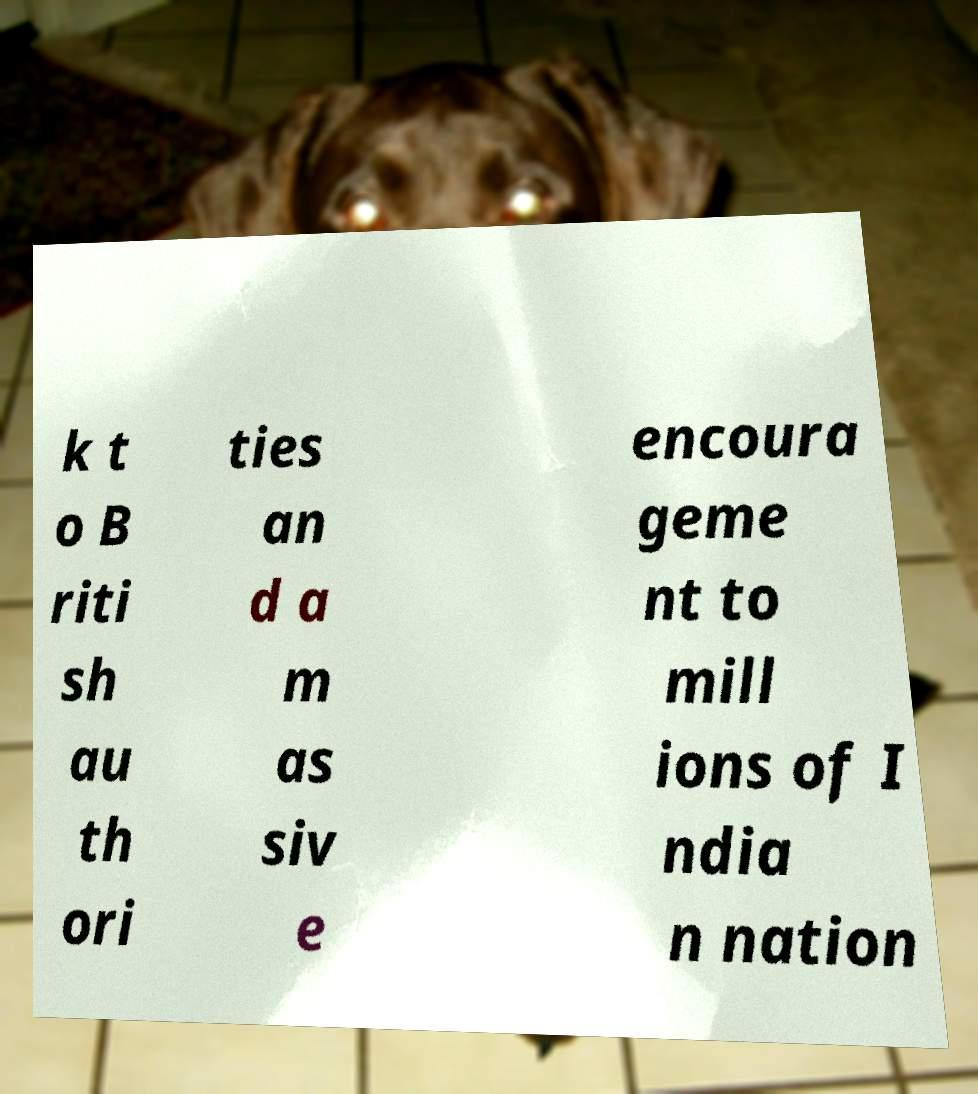Please identify and transcribe the text found in this image. k t o B riti sh au th ori ties an d a m as siv e encoura geme nt to mill ions of I ndia n nation 